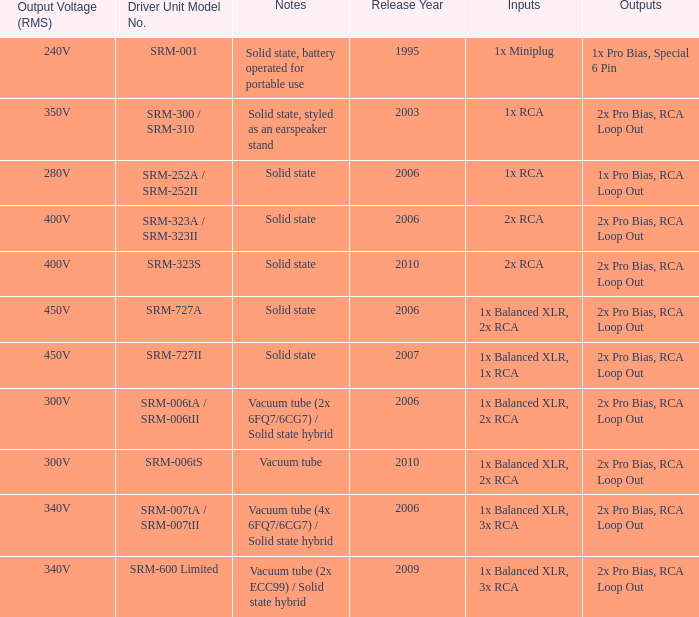What year were outputs is 2x pro bias, rca loop out and notes is vacuum tube released? 2010.0. 